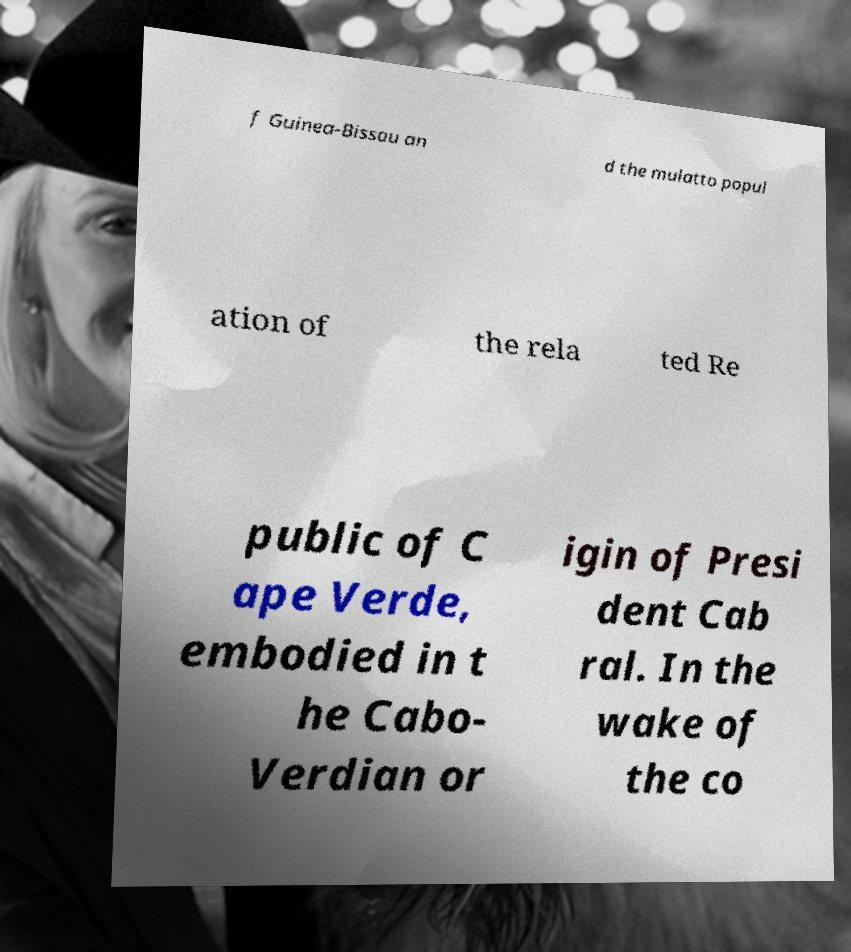Can you accurately transcribe the text from the provided image for me? f Guinea-Bissau an d the mulatto popul ation of the rela ted Re public of C ape Verde, embodied in t he Cabo- Verdian or igin of Presi dent Cab ral. In the wake of the co 